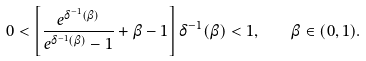Convert formula to latex. <formula><loc_0><loc_0><loc_500><loc_500>0 < \left [ \frac { e ^ { \delta ^ { - 1 } ( \beta ) } } { e ^ { \delta ^ { - 1 } ( \beta ) } - 1 } + \beta - 1 \right ] \delta ^ { - 1 } ( \beta ) < 1 , \quad \beta \in ( 0 , 1 ) .</formula> 